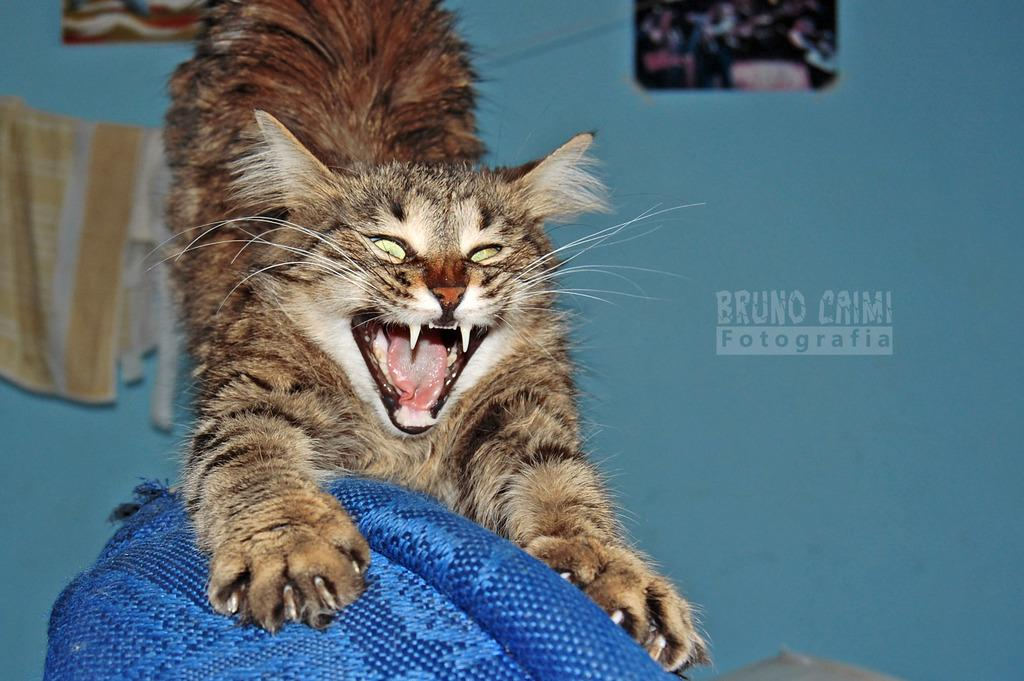What type of living creature is present in the image? There is an animal in the image. What material is present in the image? There is cloth in the image. What color is one of the objects in the image? There is a blue color object in the image. What can be seen in the background of the image? There is a wall and frames in the background of the image. Is there any indication of the image being a reproduction or copy? Yes, there is a watermark in the image. How many prisoners are visible in the image? There are no prisoners present in the image. What type of shirt is the animal wearing in the image? There is no shirt present in the image, and the animal is not wearing any clothing. 